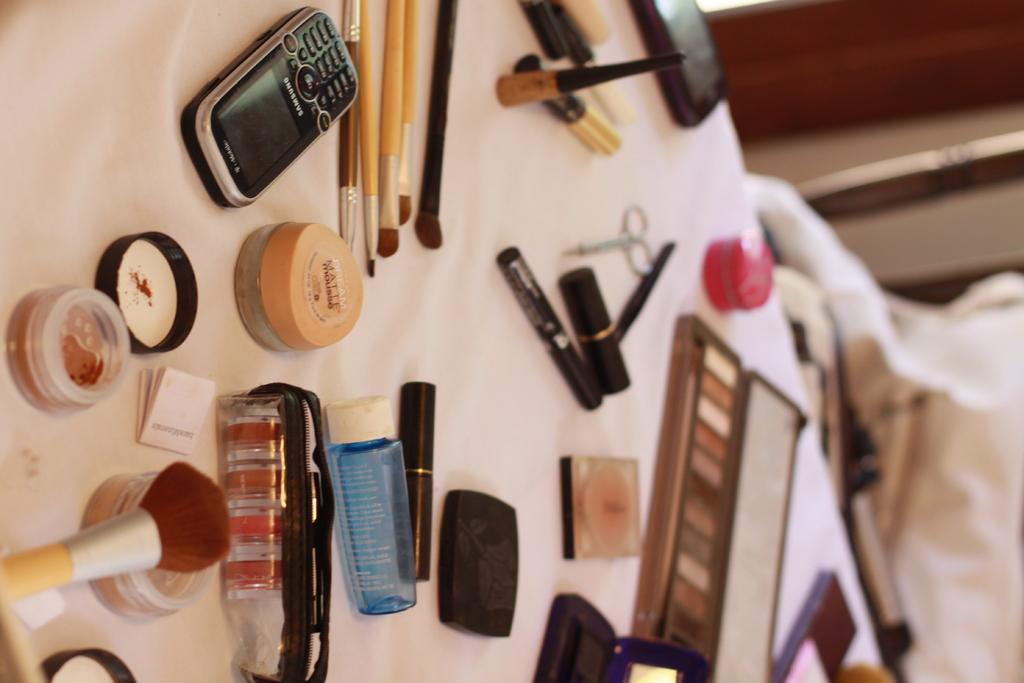What is the brand of the phone?
Give a very brief answer. Samsung. 